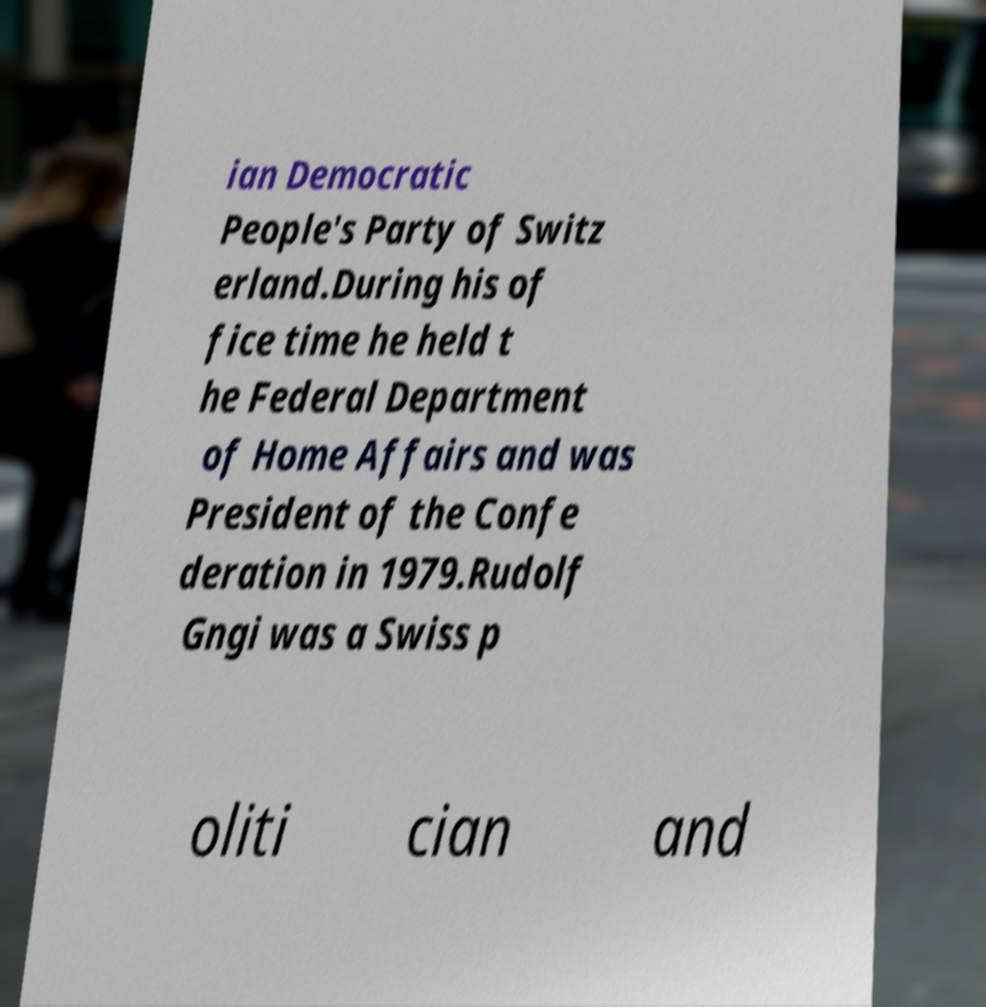For documentation purposes, I need the text within this image transcribed. Could you provide that? ian Democratic People's Party of Switz erland.During his of fice time he held t he Federal Department of Home Affairs and was President of the Confe deration in 1979.Rudolf Gngi was a Swiss p oliti cian and 